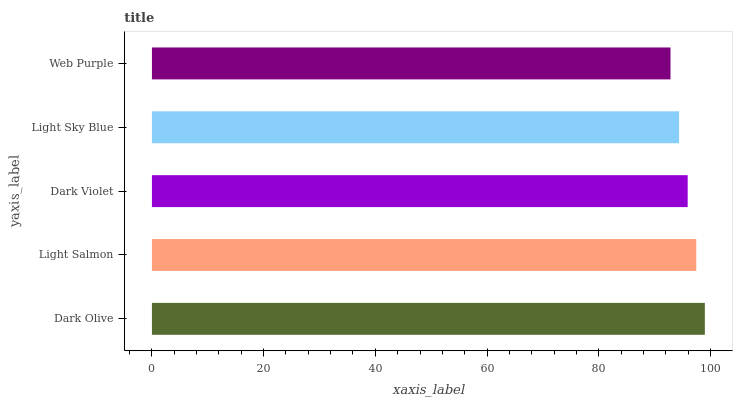Is Web Purple the minimum?
Answer yes or no. Yes. Is Dark Olive the maximum?
Answer yes or no. Yes. Is Light Salmon the minimum?
Answer yes or no. No. Is Light Salmon the maximum?
Answer yes or no. No. Is Dark Olive greater than Light Salmon?
Answer yes or no. Yes. Is Light Salmon less than Dark Olive?
Answer yes or no. Yes. Is Light Salmon greater than Dark Olive?
Answer yes or no. No. Is Dark Olive less than Light Salmon?
Answer yes or no. No. Is Dark Violet the high median?
Answer yes or no. Yes. Is Dark Violet the low median?
Answer yes or no. Yes. Is Web Purple the high median?
Answer yes or no. No. Is Dark Olive the low median?
Answer yes or no. No. 